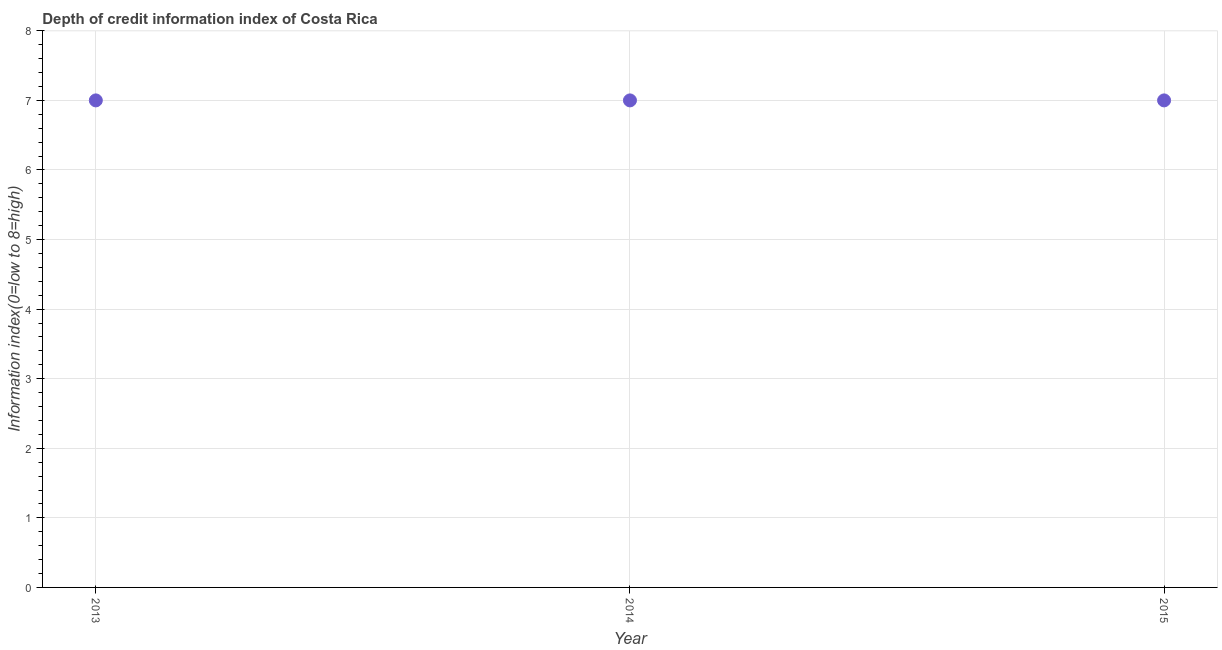What is the depth of credit information index in 2013?
Your response must be concise. 7. Across all years, what is the maximum depth of credit information index?
Offer a terse response. 7. Across all years, what is the minimum depth of credit information index?
Offer a very short reply. 7. In which year was the depth of credit information index minimum?
Your answer should be very brief. 2013. What is the sum of the depth of credit information index?
Make the answer very short. 21. What is the difference between the depth of credit information index in 2013 and 2015?
Keep it short and to the point. 0. What is the median depth of credit information index?
Your answer should be compact. 7. What is the difference between the highest and the lowest depth of credit information index?
Your answer should be compact. 0. In how many years, is the depth of credit information index greater than the average depth of credit information index taken over all years?
Offer a terse response. 0. How many dotlines are there?
Offer a terse response. 1. How many years are there in the graph?
Keep it short and to the point. 3. What is the difference between two consecutive major ticks on the Y-axis?
Provide a short and direct response. 1. Does the graph contain grids?
Your answer should be compact. Yes. What is the title of the graph?
Offer a very short reply. Depth of credit information index of Costa Rica. What is the label or title of the X-axis?
Give a very brief answer. Year. What is the label or title of the Y-axis?
Your response must be concise. Information index(0=low to 8=high). What is the Information index(0=low to 8=high) in 2013?
Your answer should be compact. 7. What is the Information index(0=low to 8=high) in 2014?
Offer a very short reply. 7. What is the difference between the Information index(0=low to 8=high) in 2013 and 2014?
Give a very brief answer. 0. What is the ratio of the Information index(0=low to 8=high) in 2013 to that in 2015?
Make the answer very short. 1. 